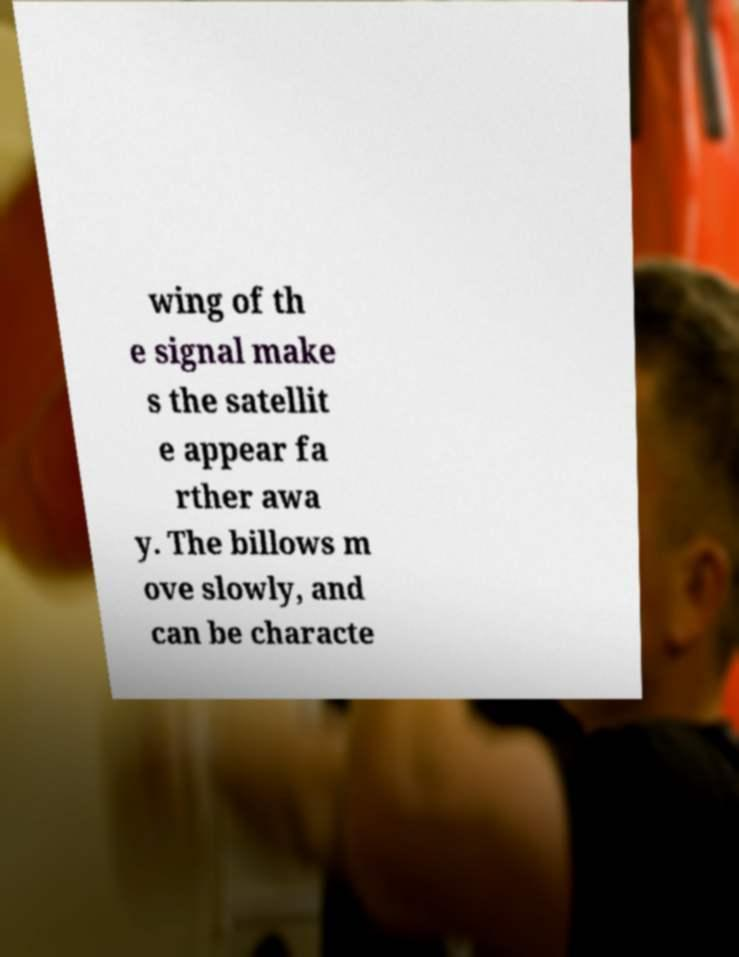Please read and relay the text visible in this image. What does it say? wing of th e signal make s the satellit e appear fa rther awa y. The billows m ove slowly, and can be characte 